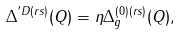Convert formula to latex. <formula><loc_0><loc_0><loc_500><loc_500>\Delta ^ { ^ { \prime } D ( r s ) } ( Q ) = \eta \Delta _ { g } ^ { ( 0 ) ( r s ) } ( Q ) ,</formula> 